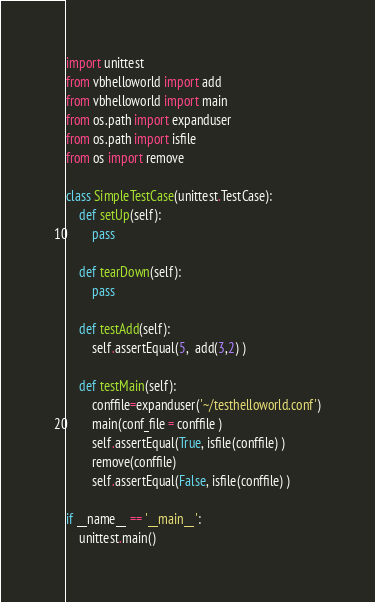Convert code to text. <code><loc_0><loc_0><loc_500><loc_500><_Python_>import unittest
from vbhelloworld import add
from vbhelloworld import main
from os.path import expanduser
from os.path import isfile
from os import remove

class SimpleTestCase(unittest.TestCase):
    def setUp(self):
        pass

    def tearDown(self):
        pass

    def testAdd(self):
        self.assertEqual(5,  add(3,2) )
        
    def testMain(self):
        conffile=expanduser('~/testhelloworld.conf')
        main(conf_file = conffile )
        self.assertEqual(True, isfile(conffile) )
        remove(conffile)
        self.assertEqual(False, isfile(conffile) )
        
if __name__ == '__main__':
    unittest.main()

</code> 